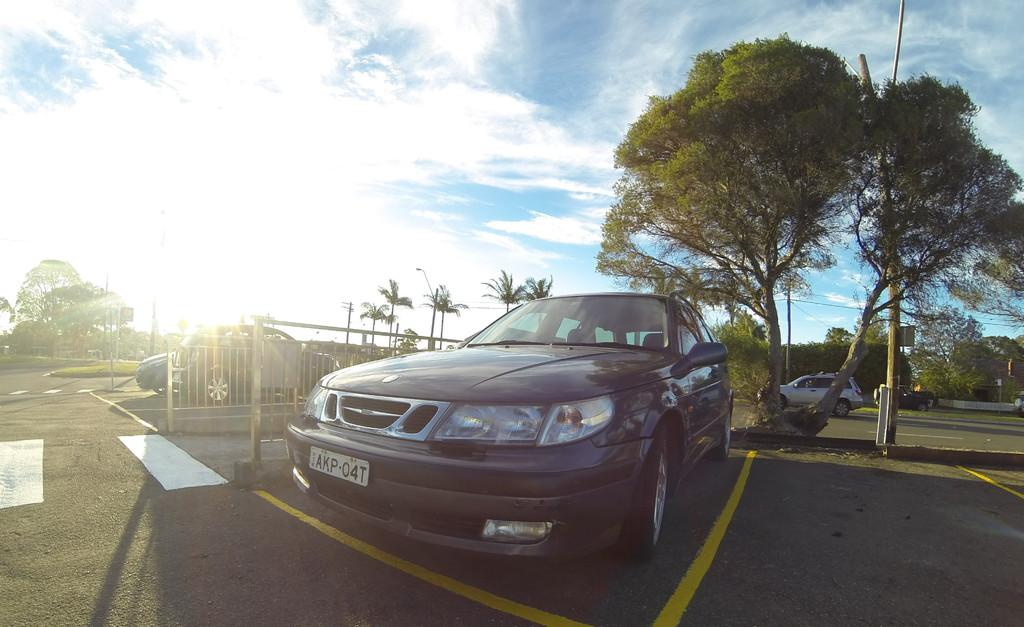What is happening on the road in the image? There are vehicles on the road in the image. Can you describe a specific detail about one of the vehicles? There is an iron grille on the left side of a car. What can be seen behind the vehicles in the image? There are poles visible behind the vehicles. What is visible in the background of the image? There are trees and the sky in the background of the image. What time of day is the woman experiencing in the image? There is no woman present in the image, so it is not possible to determine the time of day she might be experiencing. 